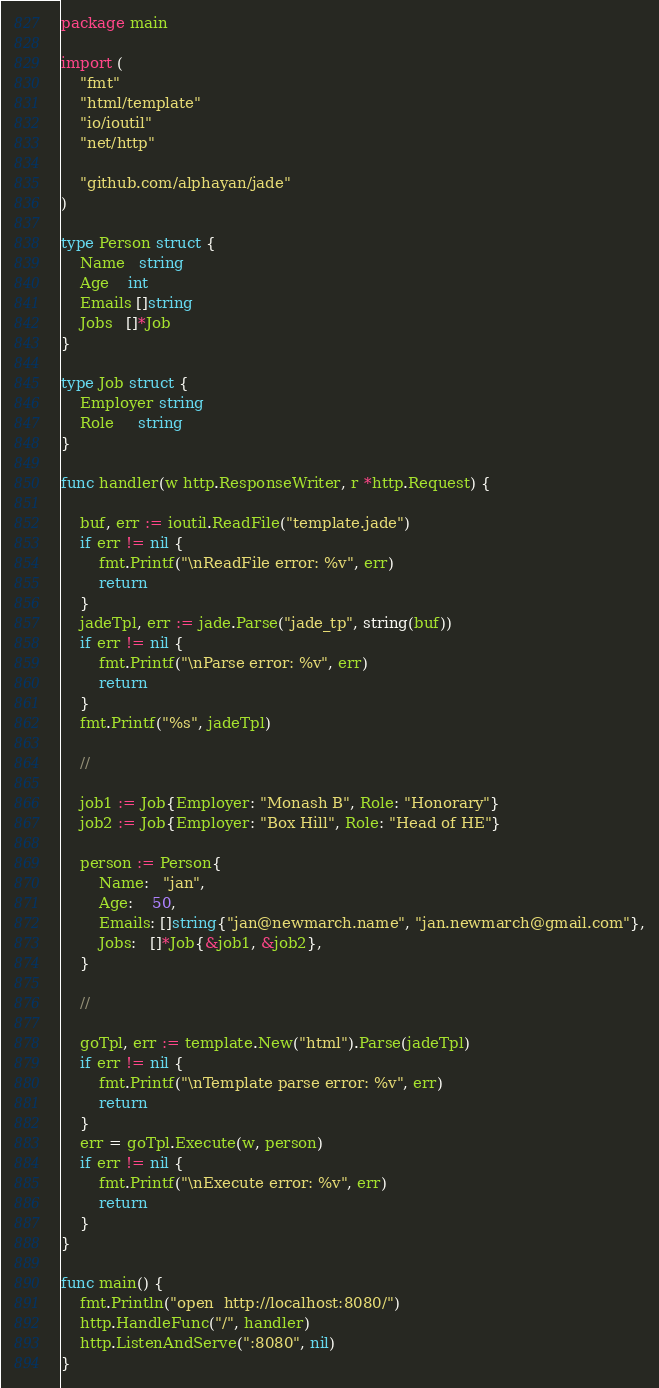Convert code to text. <code><loc_0><loc_0><loc_500><loc_500><_Go_>package main

import (
	"fmt"
	"html/template"
	"io/ioutil"
	"net/http"

	"github.com/alphayan/jade"
)

type Person struct {
	Name   string
	Age    int
	Emails []string
	Jobs   []*Job
}

type Job struct {
	Employer string
	Role     string
}

func handler(w http.ResponseWriter, r *http.Request) {

	buf, err := ioutil.ReadFile("template.jade")
	if err != nil {
		fmt.Printf("\nReadFile error: %v", err)
		return
	}
	jadeTpl, err := jade.Parse("jade_tp", string(buf))
	if err != nil {
		fmt.Printf("\nParse error: %v", err)
		return
	}
	fmt.Printf("%s", jadeTpl)

	//

	job1 := Job{Employer: "Monash B", Role: "Honorary"}
	job2 := Job{Employer: "Box Hill", Role: "Head of HE"}

	person := Person{
		Name:   "jan",
		Age:    50,
		Emails: []string{"jan@newmarch.name", "jan.newmarch@gmail.com"},
		Jobs:   []*Job{&job1, &job2},
	}

	//

	goTpl, err := template.New("html").Parse(jadeTpl)
	if err != nil {
		fmt.Printf("\nTemplate parse error: %v", err)
		return
	}
	err = goTpl.Execute(w, person)
	if err != nil {
		fmt.Printf("\nExecute error: %v", err)
		return
	}
}

func main() {
	fmt.Println("open  http://localhost:8080/")
	http.HandleFunc("/", handler)
	http.ListenAndServe(":8080", nil)
}
</code> 